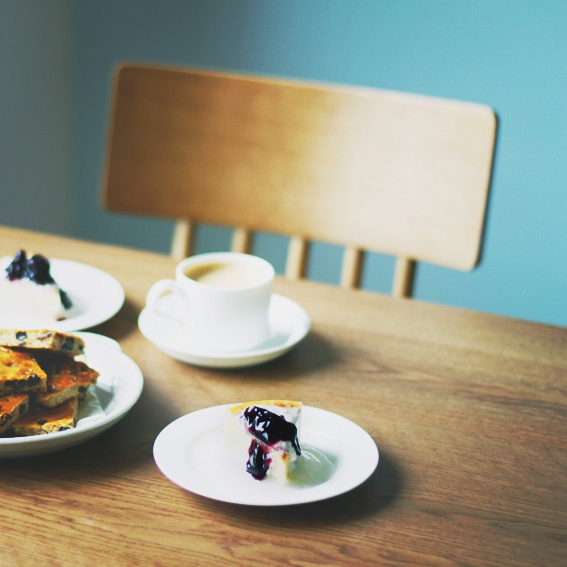Describe the objects in this image and their specific colors. I can see dining table in gray and tan tones, chair in gray, lightgray, maroon, and tan tones, bowl in gray, lightgray, and black tones, cup in gray, lightgray, beige, and tan tones, and cake in gray, black, lightgray, darkgray, and tan tones in this image. 